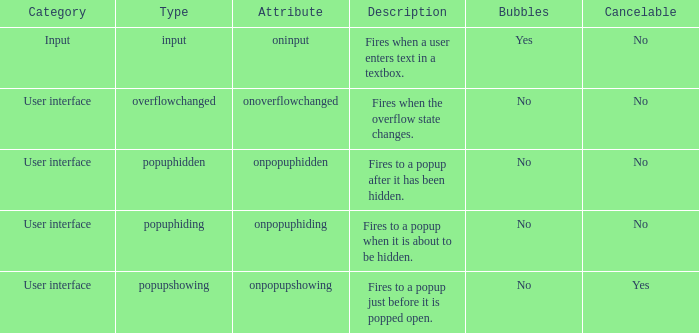What is the voidable with bubbles set to positive? No. 